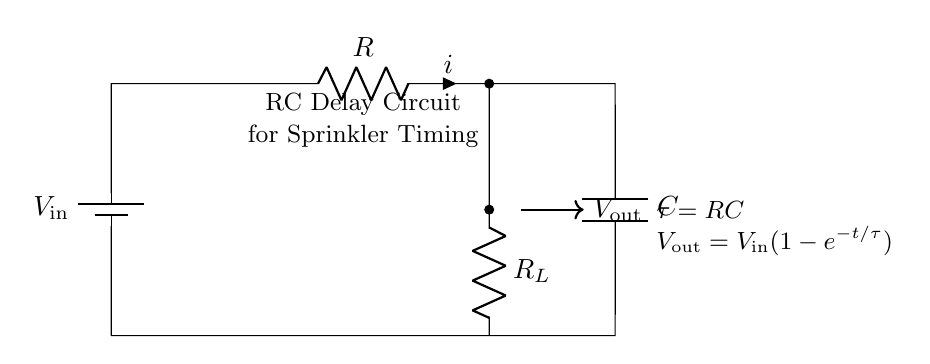What components are in the circuit? The components in the circuit include a battery, a resistor, a capacitor, and a load resistor. They are connected in a series configuration to create the RC delay circuit.
Answer: battery, resistor, capacitor, load resistor What does V_out represent in the circuit? V_out represents the output voltage across the load resistor R_L. It is the voltage that results from the charging of the capacitor through the resistor over time.
Answer: output voltage What is the time constant of the circuit? The time constant is calculated as the product of resistance and capacitance, represented by the formula tau equals RC in the diagram.
Answer: RC What is the formula for V_out? The formula for V_out indicates the output voltage as a function of input voltage over time, given by V_out equals V_in multiplied by (1 minus e to the power of negative t over tau).
Answer: V_in(1-e^{-t/\tau}) Why is the capacitor placed in the circuit? The capacitor is placed in the circuit to store charge and create a delay for the output voltage, allowing the automatic sprinkler system timing to be controlled effectively over time.
Answer: to create a delay What effect does increasing the resistance have on the time constant? Increasing the resistance directly increases the time constant, as tau is the product of resistance and capacitance. This means the output voltage will take longer to reach a certain level.
Answer: increases the time constant What happens when the circuit reaches steady state? In steady state, the capacitor is fully charged, and the output voltage V_out equals the input voltage V_in. The current in the circuit drops to zero as the capacitor acts as an open circuit.
Answer: V_out = V_in 